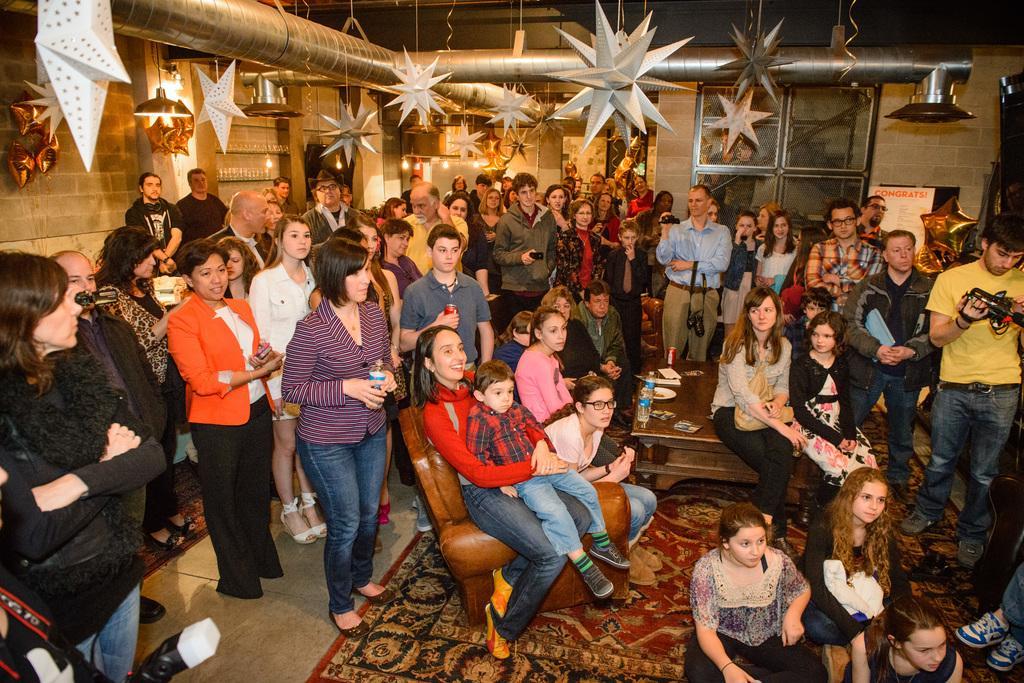Please provide a concise description of this image. In the image there are many men,women and kids standing and sitting inside a room, in the middle there is a table with few persons sitting on it and there are stars to the ceiling and lights in the background. 